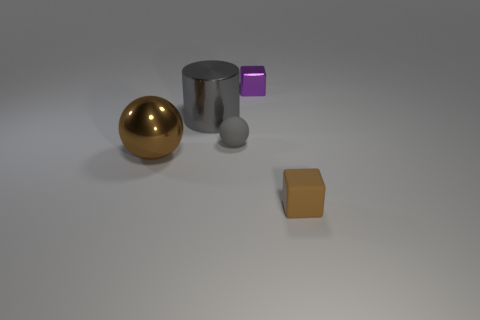The objects in the image seem to be floating. Is that accurate? Upon closer examination, the objects are not floating but are placed on a surface. The shadow beneath each object suggests they are resting on the ground and not suspended in mid-air. 